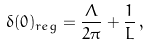Convert formula to latex. <formula><loc_0><loc_0><loc_500><loc_500>\delta ( 0 ) _ { r e g } = \frac { \Lambda } { 2 \pi } + \frac { 1 } { L } \, ,</formula> 